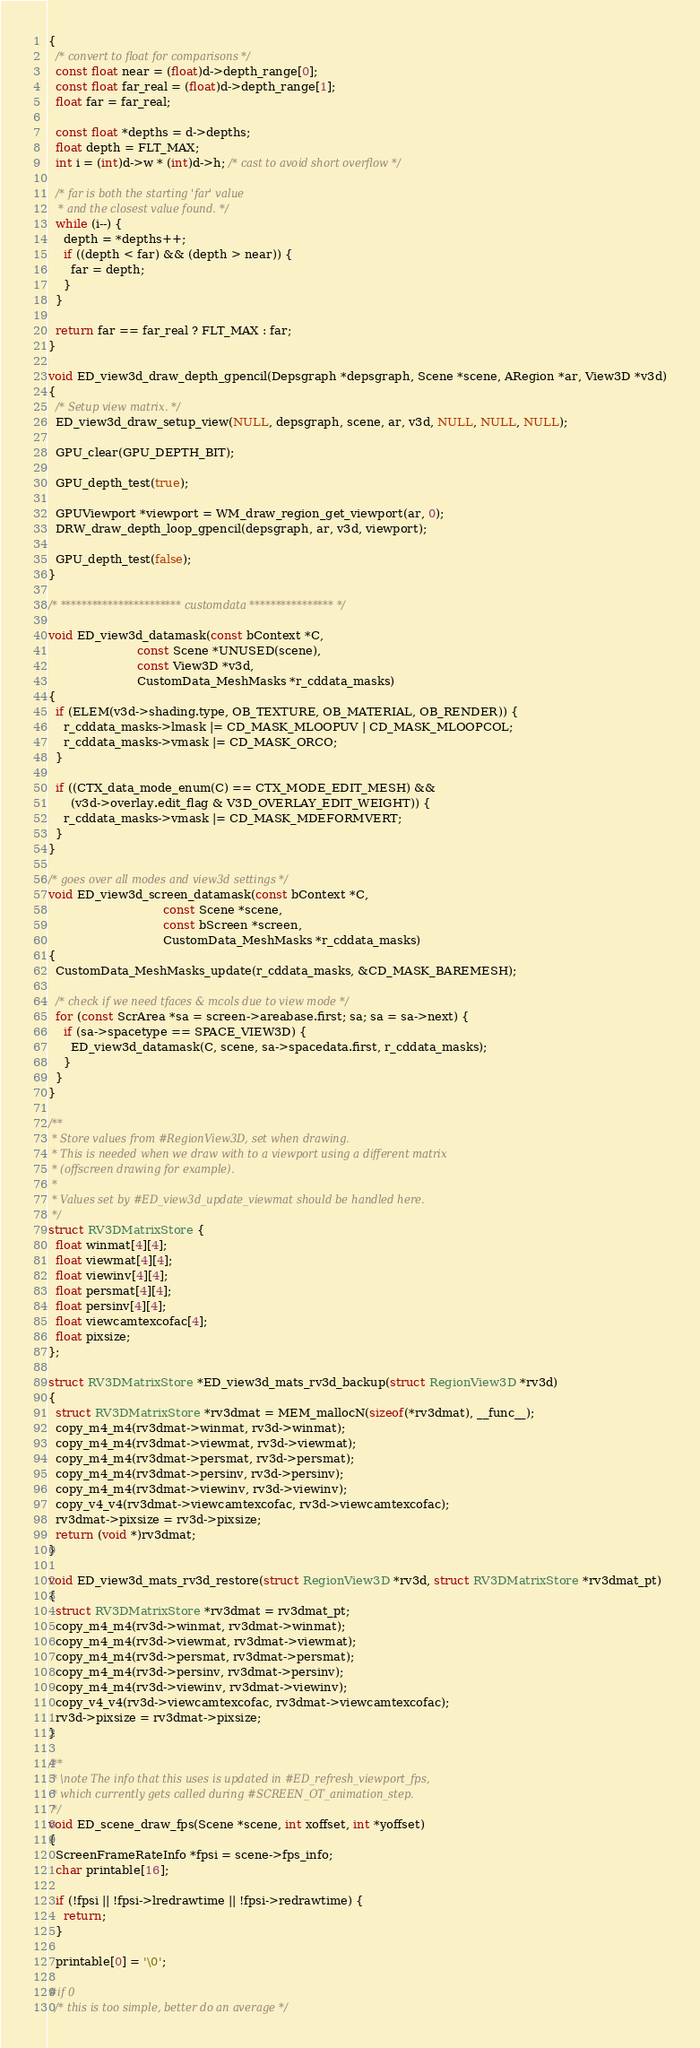<code> <loc_0><loc_0><loc_500><loc_500><_C_>{
  /* convert to float for comparisons */
  const float near = (float)d->depth_range[0];
  const float far_real = (float)d->depth_range[1];
  float far = far_real;

  const float *depths = d->depths;
  float depth = FLT_MAX;
  int i = (int)d->w * (int)d->h; /* cast to avoid short overflow */

  /* far is both the starting 'far' value
   * and the closest value found. */
  while (i--) {
    depth = *depths++;
    if ((depth < far) && (depth > near)) {
      far = depth;
    }
  }

  return far == far_real ? FLT_MAX : far;
}

void ED_view3d_draw_depth_gpencil(Depsgraph *depsgraph, Scene *scene, ARegion *ar, View3D *v3d)
{
  /* Setup view matrix. */
  ED_view3d_draw_setup_view(NULL, depsgraph, scene, ar, v3d, NULL, NULL, NULL);

  GPU_clear(GPU_DEPTH_BIT);

  GPU_depth_test(true);

  GPUViewport *viewport = WM_draw_region_get_viewport(ar, 0);
  DRW_draw_depth_loop_gpencil(depsgraph, ar, v3d, viewport);

  GPU_depth_test(false);
}

/* *********************** customdata **************** */

void ED_view3d_datamask(const bContext *C,
                        const Scene *UNUSED(scene),
                        const View3D *v3d,
                        CustomData_MeshMasks *r_cddata_masks)
{
  if (ELEM(v3d->shading.type, OB_TEXTURE, OB_MATERIAL, OB_RENDER)) {
    r_cddata_masks->lmask |= CD_MASK_MLOOPUV | CD_MASK_MLOOPCOL;
    r_cddata_masks->vmask |= CD_MASK_ORCO;
  }

  if ((CTX_data_mode_enum(C) == CTX_MODE_EDIT_MESH) &&
      (v3d->overlay.edit_flag & V3D_OVERLAY_EDIT_WEIGHT)) {
    r_cddata_masks->vmask |= CD_MASK_MDEFORMVERT;
  }
}

/* goes over all modes and view3d settings */
void ED_view3d_screen_datamask(const bContext *C,
                               const Scene *scene,
                               const bScreen *screen,
                               CustomData_MeshMasks *r_cddata_masks)
{
  CustomData_MeshMasks_update(r_cddata_masks, &CD_MASK_BAREMESH);

  /* check if we need tfaces & mcols due to view mode */
  for (const ScrArea *sa = screen->areabase.first; sa; sa = sa->next) {
    if (sa->spacetype == SPACE_VIEW3D) {
      ED_view3d_datamask(C, scene, sa->spacedata.first, r_cddata_masks);
    }
  }
}

/**
 * Store values from #RegionView3D, set when drawing.
 * This is needed when we draw with to a viewport using a different matrix
 * (offscreen drawing for example).
 *
 * Values set by #ED_view3d_update_viewmat should be handled here.
 */
struct RV3DMatrixStore {
  float winmat[4][4];
  float viewmat[4][4];
  float viewinv[4][4];
  float persmat[4][4];
  float persinv[4][4];
  float viewcamtexcofac[4];
  float pixsize;
};

struct RV3DMatrixStore *ED_view3d_mats_rv3d_backup(struct RegionView3D *rv3d)
{
  struct RV3DMatrixStore *rv3dmat = MEM_mallocN(sizeof(*rv3dmat), __func__);
  copy_m4_m4(rv3dmat->winmat, rv3d->winmat);
  copy_m4_m4(rv3dmat->viewmat, rv3d->viewmat);
  copy_m4_m4(rv3dmat->persmat, rv3d->persmat);
  copy_m4_m4(rv3dmat->persinv, rv3d->persinv);
  copy_m4_m4(rv3dmat->viewinv, rv3d->viewinv);
  copy_v4_v4(rv3dmat->viewcamtexcofac, rv3d->viewcamtexcofac);
  rv3dmat->pixsize = rv3d->pixsize;
  return (void *)rv3dmat;
}

void ED_view3d_mats_rv3d_restore(struct RegionView3D *rv3d, struct RV3DMatrixStore *rv3dmat_pt)
{
  struct RV3DMatrixStore *rv3dmat = rv3dmat_pt;
  copy_m4_m4(rv3d->winmat, rv3dmat->winmat);
  copy_m4_m4(rv3d->viewmat, rv3dmat->viewmat);
  copy_m4_m4(rv3d->persmat, rv3dmat->persmat);
  copy_m4_m4(rv3d->persinv, rv3dmat->persinv);
  copy_m4_m4(rv3d->viewinv, rv3dmat->viewinv);
  copy_v4_v4(rv3d->viewcamtexcofac, rv3dmat->viewcamtexcofac);
  rv3d->pixsize = rv3dmat->pixsize;
}

/**
 * \note The info that this uses is updated in #ED_refresh_viewport_fps,
 * which currently gets called during #SCREEN_OT_animation_step.
 */
void ED_scene_draw_fps(Scene *scene, int xoffset, int *yoffset)
{
  ScreenFrameRateInfo *fpsi = scene->fps_info;
  char printable[16];

  if (!fpsi || !fpsi->lredrawtime || !fpsi->redrawtime) {
    return;
  }

  printable[0] = '\0';

#if 0
  /* this is too simple, better do an average */</code> 